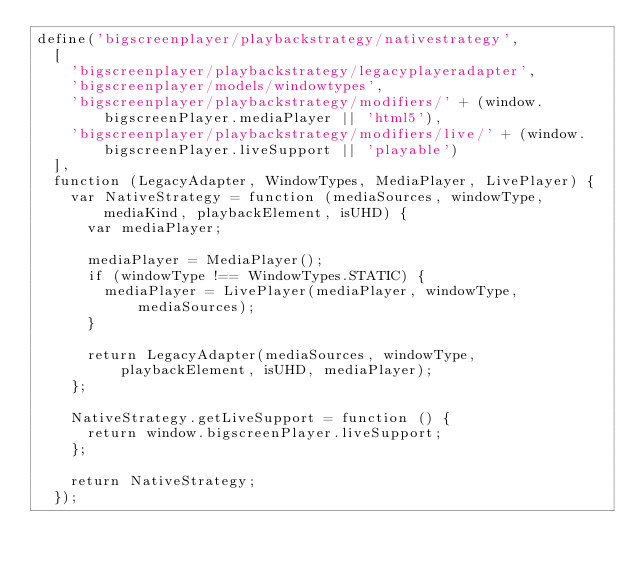Convert code to text. <code><loc_0><loc_0><loc_500><loc_500><_JavaScript_>define('bigscreenplayer/playbackstrategy/nativestrategy',
  [
    'bigscreenplayer/playbackstrategy/legacyplayeradapter',
    'bigscreenplayer/models/windowtypes',
    'bigscreenplayer/playbackstrategy/modifiers/' + (window.bigscreenPlayer.mediaPlayer || 'html5'),
    'bigscreenplayer/playbackstrategy/modifiers/live/' + (window.bigscreenPlayer.liveSupport || 'playable')
  ],
  function (LegacyAdapter, WindowTypes, MediaPlayer, LivePlayer) {
    var NativeStrategy = function (mediaSources, windowType, mediaKind, playbackElement, isUHD) {
      var mediaPlayer;

      mediaPlayer = MediaPlayer();
      if (windowType !== WindowTypes.STATIC) {
        mediaPlayer = LivePlayer(mediaPlayer, windowType, mediaSources);
      }

      return LegacyAdapter(mediaSources, windowType, playbackElement, isUHD, mediaPlayer);
    };

    NativeStrategy.getLiveSupport = function () {
      return window.bigscreenPlayer.liveSupport;
    };

    return NativeStrategy;
  });
</code> 